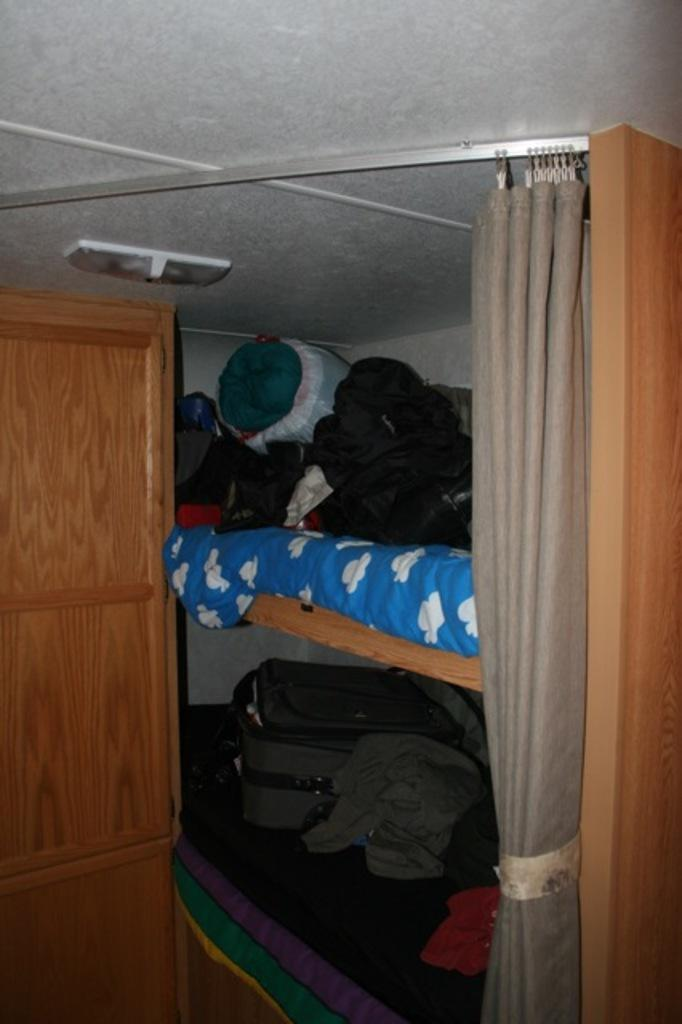What is located in the center of the image? There is a shelf in the center of the image. What items can be seen on the shelf? Clothes, a pillow, and a bag are placed on the shelf. What is visible on the right side of the image? There is a curtain on the right side of the image. What can be seen at the top of the image? There is a light at the top of the image. What type of yam is being cooked in the oven in the image? There is no oven or yam present in the image; it features a shelf with clothes, a pillow, and a bag, along with a curtain and a light. 